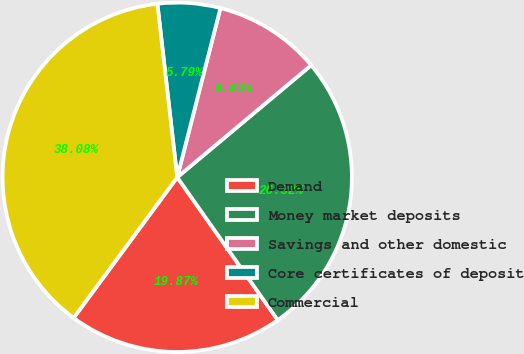Convert chart. <chart><loc_0><loc_0><loc_500><loc_500><pie_chart><fcel>Demand<fcel>Money market deposits<fcel>Savings and other domestic<fcel>Core certificates of deposit<fcel>Commercial<nl><fcel>19.87%<fcel>26.32%<fcel>9.93%<fcel>5.79%<fcel>38.08%<nl></chart> 